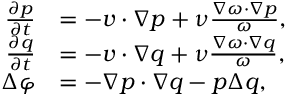<formula> <loc_0><loc_0><loc_500><loc_500>\begin{array} { r l } { \frac { \partial p } { \partial t } } & { = - v \cdot \nabla p + \nu \frac { \nabla \omega \cdot \nabla p } { \omega } , } \\ { \frac { \partial q } { \partial t } } & { = - v \cdot \nabla q + \nu \frac { \nabla \omega \cdot \nabla q } { \omega } , } \\ { \Delta \varphi } & { = - \nabla p \cdot \nabla q - p \Delta q , } \end{array}</formula> 